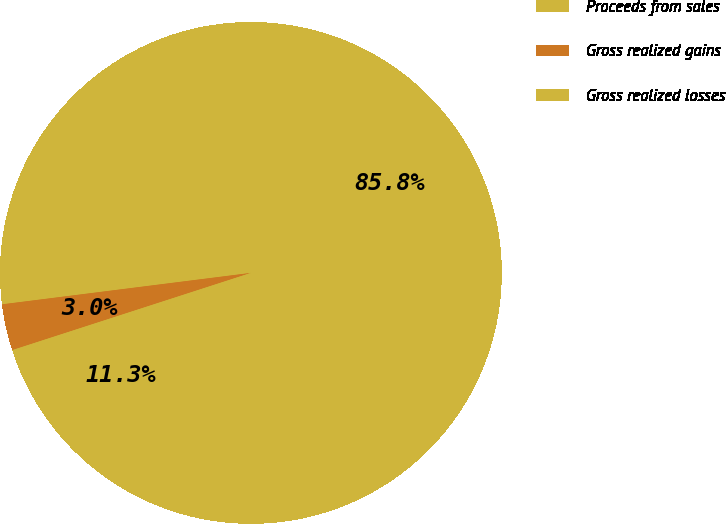Convert chart to OTSL. <chart><loc_0><loc_0><loc_500><loc_500><pie_chart><fcel>Proceeds from sales<fcel>Gross realized gains<fcel>Gross realized losses<nl><fcel>85.76%<fcel>2.98%<fcel>11.26%<nl></chart> 